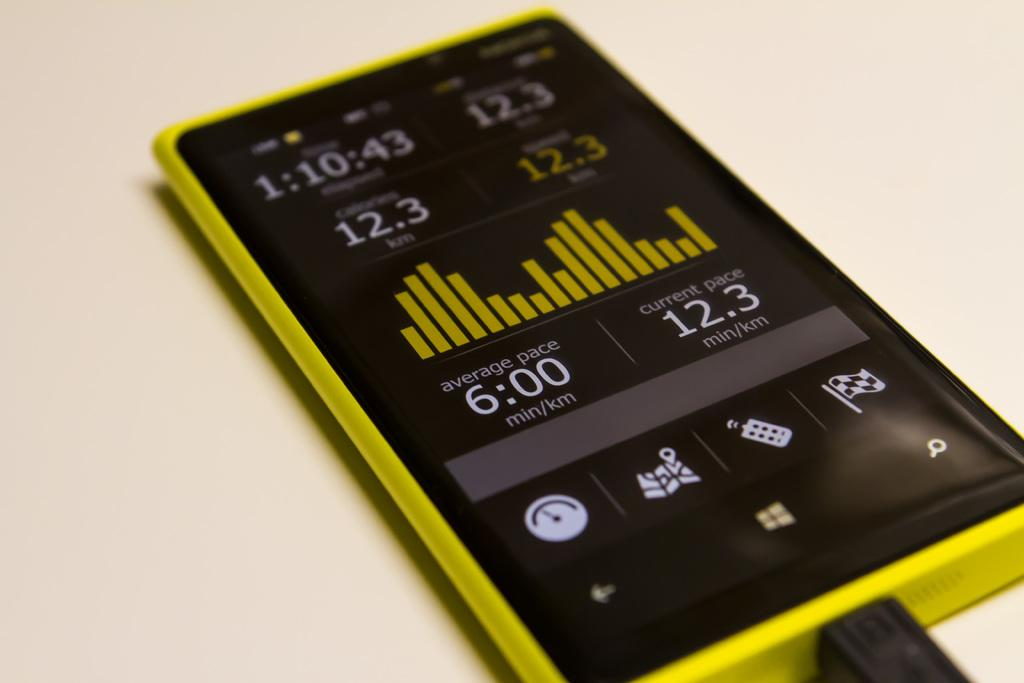Provide a one-sentence caption for the provided image. someone's phone with an app that reports average and current paces. 